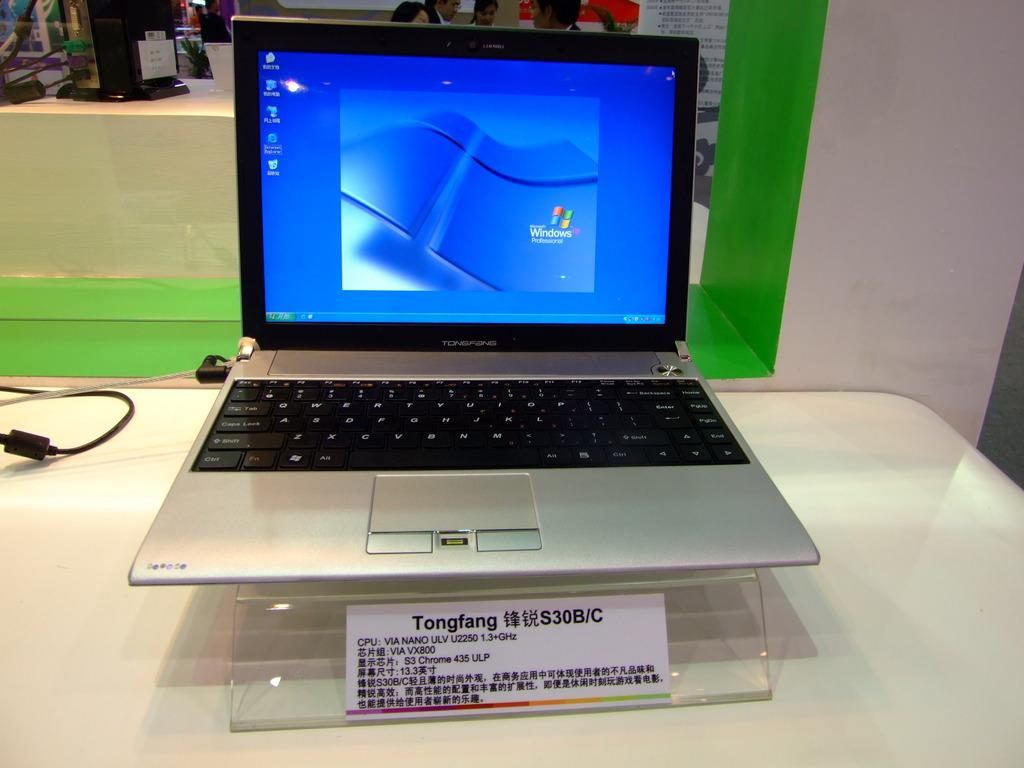What electronic device is present in the image? There is a laptop in the image. Where is the laptop located? The laptop is placed on a table. Can you describe any other people or objects visible in the image? There are people visible on the back side of the image. What type of throat lozenges can be seen on the laptop in the image? There are no throat lozenges present on the laptop in the image. Can you describe the road conditions visible in the image? There is no road visible in the image; it only features a laptop on a table and people on the back side. 